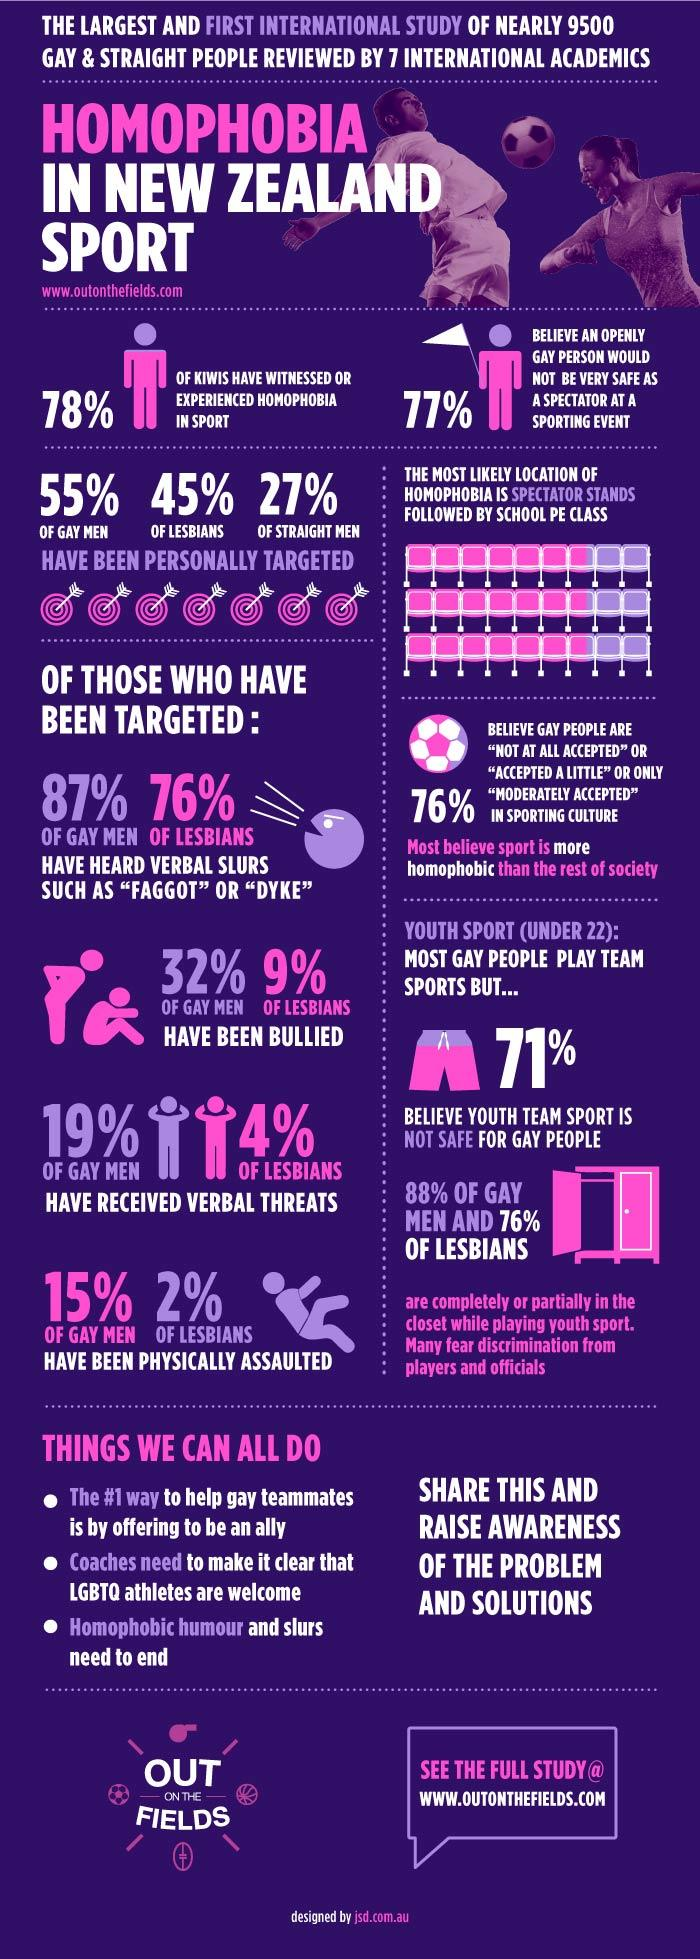Draw attention to some important aspects in this diagram. The idea that gay men have been bullied more than lesbian individuals is a common belief. 